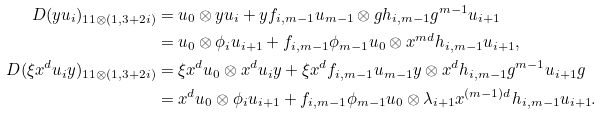<formula> <loc_0><loc_0><loc_500><loc_500>\ D ( y u _ { i } ) _ { 1 1 \otimes ( 1 , 3 + 2 i ) } & = u _ { 0 } \otimes y u _ { i } + y f _ { i , m - 1 } u _ { m - 1 } \otimes g h _ { i , m - 1 } g ^ { m - 1 } u _ { i + 1 } \\ & = u _ { 0 } \otimes \phi _ { i } u _ { i + 1 } + f _ { i , m - 1 } \phi _ { m - 1 } u _ { 0 } \otimes x ^ { m d } h _ { i , m - 1 } u _ { i + 1 } , \\ \ D ( \xi x ^ { d } u _ { i } y ) _ { 1 1 \otimes ( 1 , 3 + 2 i ) } & = \xi x ^ { d } u _ { 0 } \otimes x ^ { d } u _ { i } y + \xi x ^ { d } f _ { i , m - 1 } u _ { m - 1 } y \otimes x ^ { d } h _ { i , m - 1 } g ^ { m - 1 } u _ { i + 1 } g \\ & = x ^ { d } u _ { 0 } \otimes \phi _ { i } u _ { i + 1 } + f _ { i , m - 1 } \phi _ { m - 1 } u _ { 0 } \otimes \lambda _ { i + 1 } x ^ { ( m - 1 ) d } h _ { i , m - 1 } u _ { i + 1 } .</formula> 